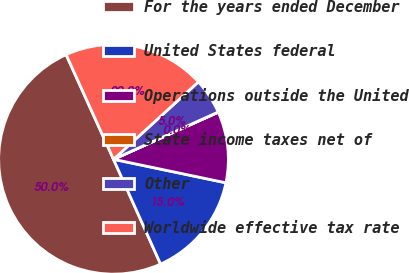<chart> <loc_0><loc_0><loc_500><loc_500><pie_chart><fcel>For the years ended December<fcel>United States federal<fcel>Operations outside the United<fcel>State income taxes net of<fcel>Other<fcel>Worldwide effective tax rate<nl><fcel>49.95%<fcel>15.0%<fcel>10.01%<fcel>0.02%<fcel>5.02%<fcel>20.0%<nl></chart> 